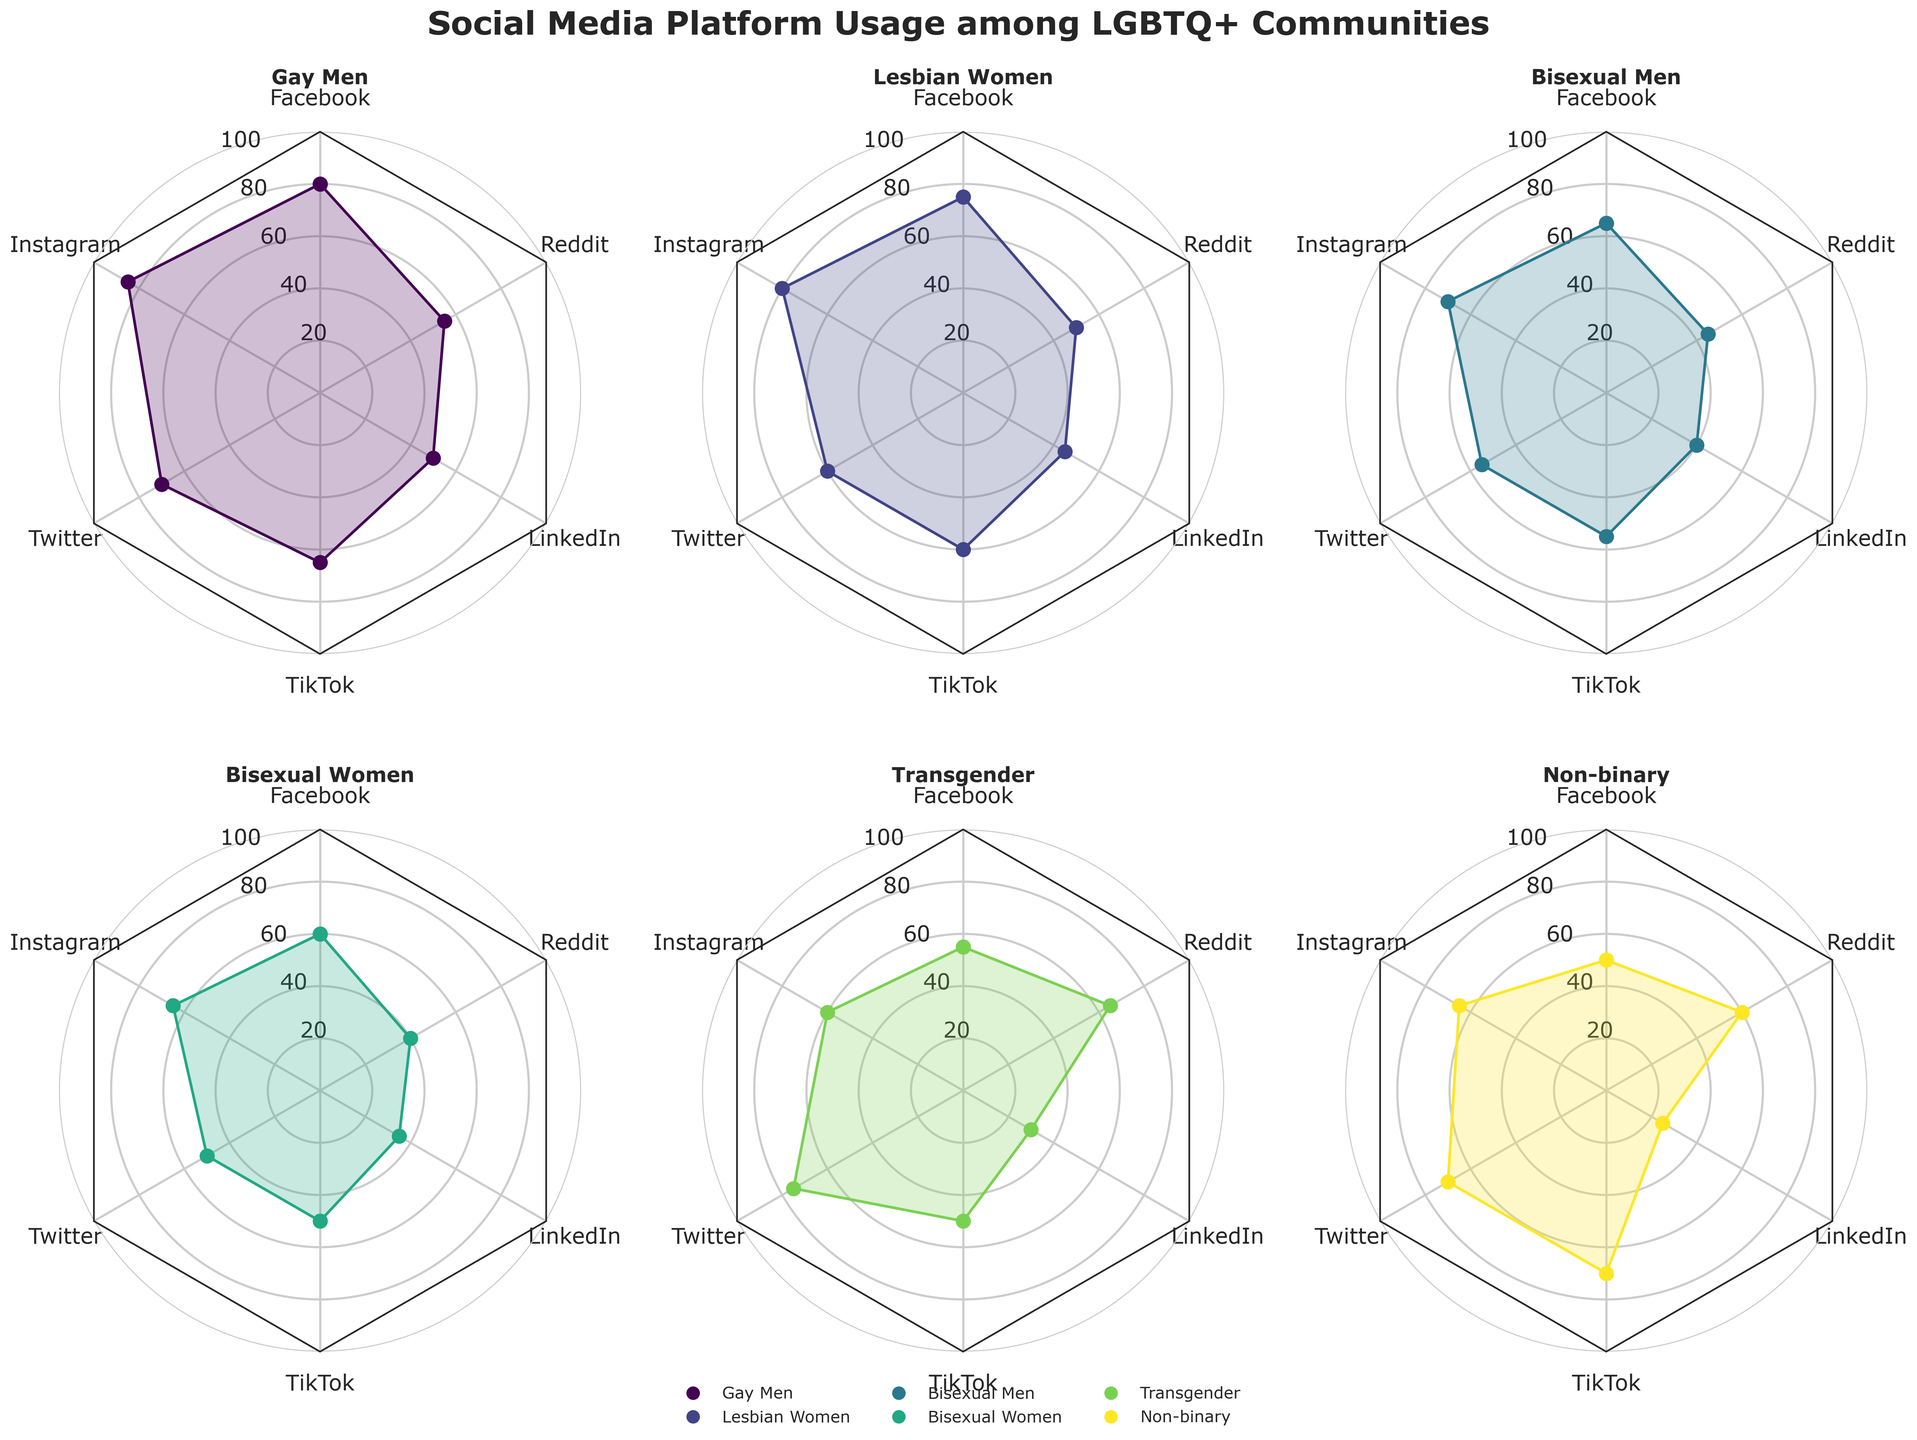What is the title of the figure? The title of the figure is usually placed at the top and is meant to summarize the content of the figure in a concise manner. By looking at the title text, you can easily identify the main subject or theme of the figure.
Answer: Social Media Platform Usage among LGBTQ+ Communities Which community has the highest Facebook usage percentage? To find which community has the highest usage percentage for Facebook, observe the radar chart segment representing Facebook for each community. Identify the community with the highest value on this axis.
Answer: Gay Men What is the approximate average Instagram usage percentage across all communities? To find the average Instagram usage percentage, first note the usage percentages for each community (Gay Men: 85, Lesbian Women: 80, Bisexual Men: 70, Bisexual Women: 65, Transgender: 60, Non-binary: 65). Sum these values and then divide by the number of communities. Calculation: (85 + 80 + 70 + 65 + 60 + 65) / 6 = 425 / 6 ≈ 70.83
Answer: 70.83 Which platform shows the least variation in usage percentages among different communities? Observe each platform's segments across the communities and look for the platform where the usage percentages are most similar. This can be identified if the data points for the platform form a near-circular or uniformly distributed pattern.
Answer: LinkedIn Between Instagram and Twitter, which platform has higher usage among Transgender individuals? Compare the values on the radar charts for Transgender individuals, looking specifically at the segments for Instagram and Twitter. Identify which segment has a higher value.
Answer: Twitter What is the difference in percentage usage of Reddit between Bisexual Women and Non-binary individuals? Find the usage percentages for Reddit among Bisexual Women and Non-binary individuals on the radar chart. Bisexual Women's usage is 40%, and Non-binary individuals' usage is 60%. Subtract the smaller value from the larger value: 60 - 40 = 20.
Answer: 20 Which community shows almost equal usage of Instagram and Twitter? Look at each community's radar chart and compare the values for Instagram and Twitter. The community where these values are closest indicates almost equal usage.
Answer: Non-binary What is the combined usage percentage for Facebook and TikTok among Gay Men? Find the usage percentages for both Facebook and TikTok for Gay Men on the radar chart. Facebook usage is 80%, and TikTok usage is 65%. Add these values: 80 + 65 = 145.
Answer: 145 Is the Facebook usage for Transgender individuals greater than the LinkedIn usage for Bisexual Men? Compare the Facebook usage percentage for Transgender individuals (55%) and LinkedIn usage percentage for Bisexual Men (40%). Since 55% is greater than 40%, the answer is yes.
Answer: Yes 